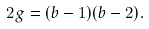Convert formula to latex. <formula><loc_0><loc_0><loc_500><loc_500>2 g = ( b - 1 ) ( b - 2 ) .</formula> 